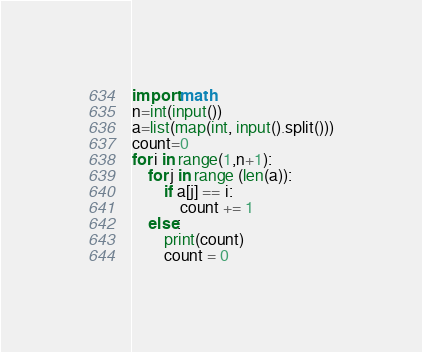Convert code to text. <code><loc_0><loc_0><loc_500><loc_500><_Python_>import math
n=int(input())
a=list(map(int, input().split()))
count=0
for i in range(1,n+1):
    for j in range (len(a)):
        if a[j] == i:
            count += 1
    else:
        print(count)
        count = 0</code> 